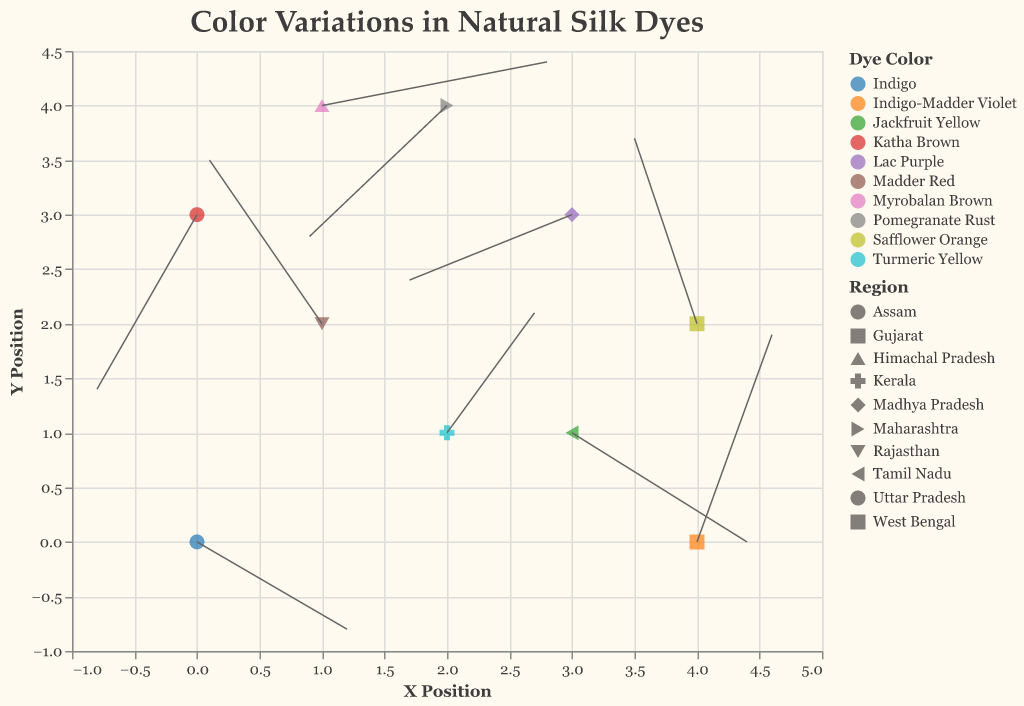What does the figure's title tell us about the content? The title "Color Variations in Natural Silk Dyes" indicates that the figure displays how different natural dye colors vary, possibly influenced by regional climate conditions.
Answer: Color Variations in Natural Silk Dyes How many different dye colors are represented in the plot? By counting the distinct colors listed in the legend, we notice there are 10 different dye colors.
Answer: 10 Which region corresponds to Myrobalan Brown, and what are its vector components (u, v)? By checking the tooltip for Myrobalan Brown, we see it corresponds to Himachal Pradesh, and the vector components are (1.8, 0.4).
Answer: Himachal Pradesh, (1.8, 0.4) Compare the vectors for Pomegranate Rust and Safflower Orange. Which one has a larger magnitude and what are the magnitudes? To find the magnitudes, we use the formula sqrt(u^2 + v^2). For Pomegranate Rust: sqrt((-1.1)^2 + (-1.2)^2) ≈ 1.63, and for Safflower Orange: sqrt((-0.5)^2 + (1.7)^2) ≈ 1.77. Safflower Orange has a larger magnitude.
Answer: Safflower Orange, 1.77; Pomegranate Rust, 1.63 What is the average x component (u) of the vectors plotted? Adding all x components (1.2, -0.9, 0.7, -1.3, 1.8, -0.5, -1.1, 0.6, 1.4, -0.8) and dividing by the number of vectors (10), the average is (1.2 - 0.9 + 0.7 - 1.3 + 1.8 - 0.5 - 1.1 + 0.6 + 1.4 - 0.8)/10 = 0.11.
Answer: 0.11 Which region has the vector closest to the origin and what are its coordinates (x, y)? Checking each region’s coordinates, the closest to the origin (0,0) is the one with coordinates (0,0) itself, which is Assam.
Answer: Assam, (0,0) What direction does the vector for Turmeric Yellow point? By analyzing the vector components for Turmeric Yellow (0.7, 1.1), the vector points positively along both x and y axes.
Answer: Positive x and y directions Which dye color has the most vectors pointing towards the positive y direction? Counting the vectors with positive v components, Jackfruit Yellow, Safflower Orange, Madder Red, Turmeric Yellow, and Myrobalan Brown point towards the positive y direction.
Answer: 5 vectors What are the starting coordinates of the vector corresponding to Katha Brown? Referring to the data for Katha Brown, the starting coordinates are (0, 3).
Answer: (0, 3) 